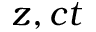<formula> <loc_0><loc_0><loc_500><loc_500>z , c t</formula> 